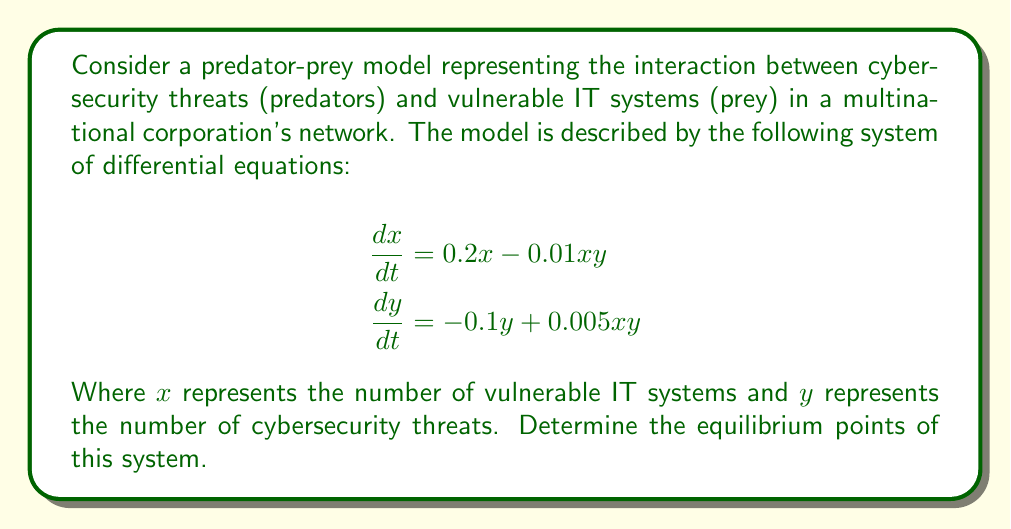Could you help me with this problem? To find the equilibrium points, we need to set both equations equal to zero and solve for x and y:

1) Set $\frac{dx}{dt} = 0$ and $\frac{dy}{dt} = 0$:

   $$\begin{aligned}
   0 &= 0.2x - 0.01xy \\
   0 &= -0.1y + 0.005xy
   \end{aligned}$$

2) From the first equation:
   $$0.2x - 0.01xy = 0$$
   $$x(0.2 - 0.01y) = 0$$
   
   This gives us two possibilities: $x = 0$ or $0.2 - 0.01y = 0$

3) If $x = 0$, from the second equation:
   $$0 = -0.1y + 0.005(0)y = -0.1y$$
   This is true when $y = 0$

   So, one equilibrium point is $(0, 0)$

4) If $0.2 - 0.01y = 0$, then:
   $$y = 20$$

5) Substitute $y = 20$ into the second equation:
   $$0 = -0.1(20) + 0.005x(20)$$
   $$2 = 0.1x$$
   $$x = 20$$

   So, the second equilibrium point is $(20, 20)$

Therefore, there are two equilibrium points: $(0, 0)$ and $(20, 20)$.
Answer: $(0, 0)$ and $(20, 20)$ 